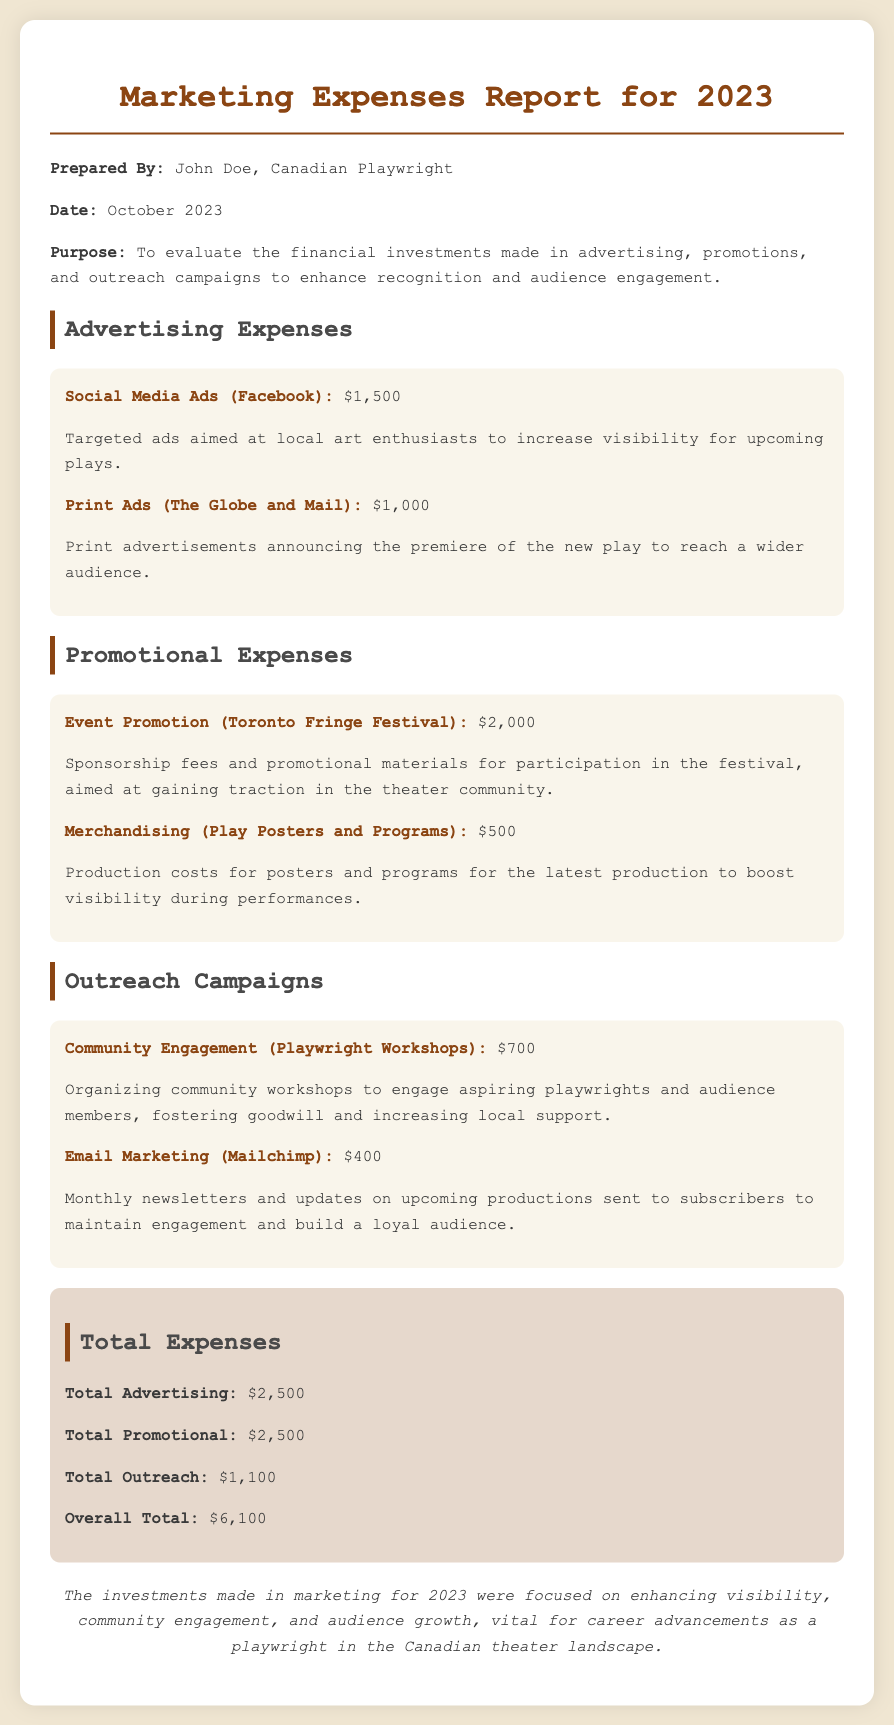What is the total amount spent on advertising? The total advertising expenses are detailed in the section and amount to $2,500.
Answer: $2,500 Who prepared the report? The document specifies that it was prepared by John Doe.
Answer: John Doe What was the expense for Event Promotion at the Toronto Fringe Festival? The amount allocated for Event Promotion is stated as $2,000.
Answer: $2,000 What is the expenditure on Email Marketing? Email Marketing expenses are listed as $400 in the document.
Answer: $400 What is the overall total of all expenses listed? The report sums up the total expenses, which amounts to $6,100.
Answer: $6,100 How much was spent on Merchandising for Play Posters and Programs? The expense for Merchandising is explicitly mentioned as $500.
Answer: $500 What was the purpose of the investments made, as mentioned in the report? The purpose is to evaluate investments aimed at enhancing recognition and audience engagement.
Answer: Enhance recognition and audience engagement How does the total outreach expenditure compare to the total advertising expenditure? The total outreach spending is $1,100, which is significantly less than total advertising of $2,500.
Answer: $1,100 What is the date when the report was prepared? The document states the date of preparation as October 2023.
Answer: October 2023 